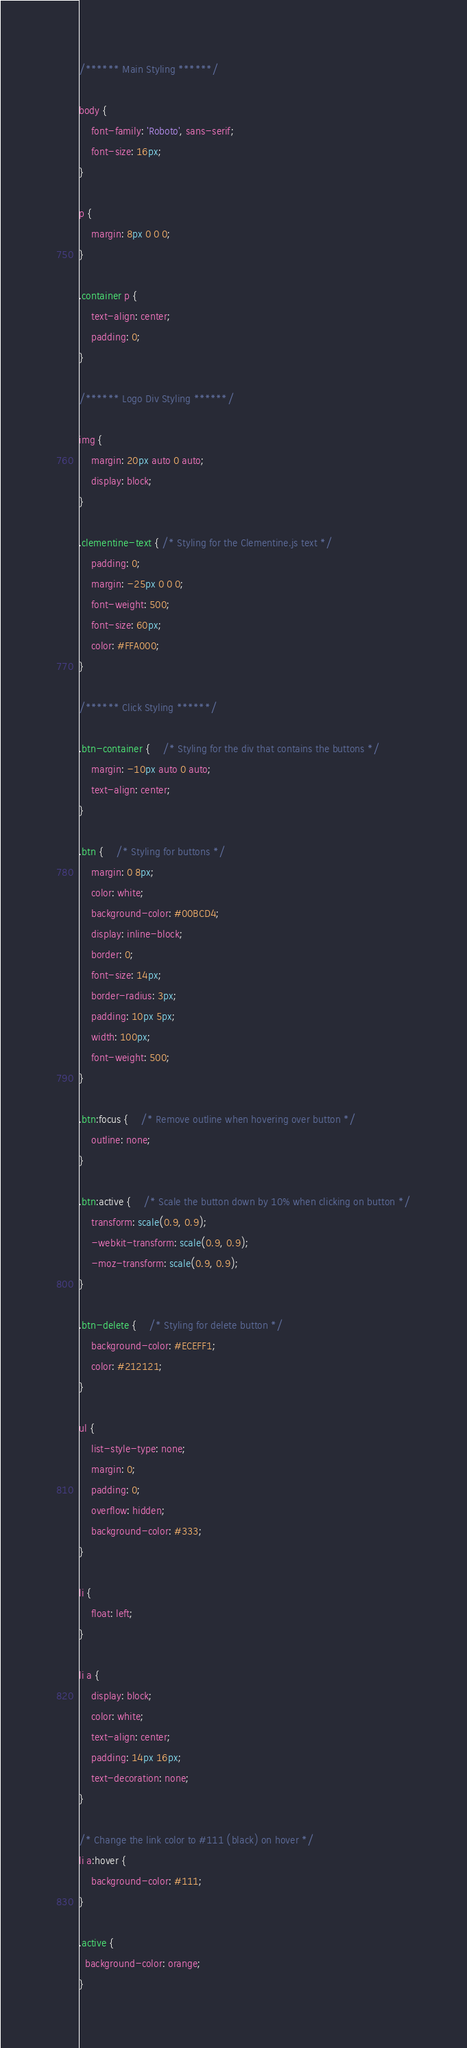<code> <loc_0><loc_0><loc_500><loc_500><_CSS_>/****** Main Styling ******/

body {
	font-family: 'Roboto', sans-serif;
	font-size: 16px;
}

p {
	margin: 8px 0 0 0;
}

.container p {
	text-align: center;
	padding: 0;
}

/****** Logo Div Styling ******/

img {
	margin: 20px auto 0 auto;
	display: block;
}

.clementine-text { /* Styling for the Clementine.js text */
	padding: 0;
	margin: -25px 0 0 0;
	font-weight: 500;
	font-size: 60px;
	color: #FFA000;
}

/****** Click Styling ******/

.btn-container {	/* Styling for the div that contains the buttons */
	margin: -10px auto 0 auto;
	text-align: center;
}

.btn {	/* Styling for buttons */
	margin: 0 8px;
	color: white;
	background-color: #00BCD4;
	display: inline-block;
	border: 0;
	font-size: 14px;
	border-radius: 3px;
	padding: 10px 5px;
	width: 100px;
	font-weight: 500;
}

.btn:focus {	/* Remove outline when hovering over button */
	outline: none;
}

.btn:active {	/* Scale the button down by 10% when clicking on button */
	transform: scale(0.9, 0.9);
	-webkit-transform: scale(0.9, 0.9);
	-moz-transform: scale(0.9, 0.9);
}

.btn-delete {	/* Styling for delete button */
	background-color: #ECEFF1;
	color: #212121;
}

ul {
    list-style-type: none;
    margin: 0;
    padding: 0;
    overflow: hidden;
    background-color: #333;
}

li {
    float: left;
}

li a {
    display: block;
    color: white;
    text-align: center;
    padding: 14px 16px;
    text-decoration: none;
}

/* Change the link color to #111 (black) on hover */
li a:hover {
    background-color: #111;
}

.active {
  background-color: orange;
}</code> 